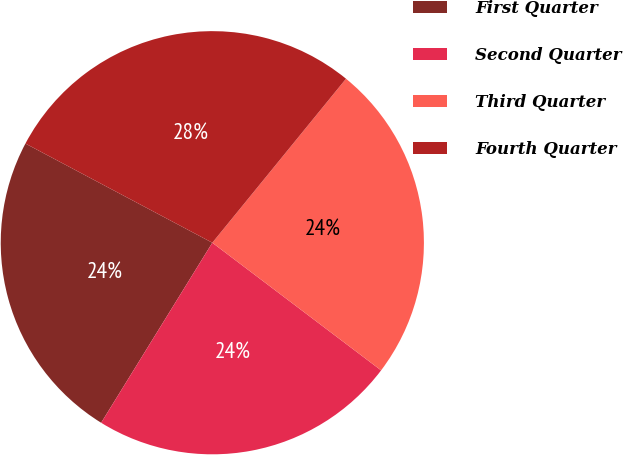Convert chart to OTSL. <chart><loc_0><loc_0><loc_500><loc_500><pie_chart><fcel>First Quarter<fcel>Second Quarter<fcel>Third Quarter<fcel>Fourth Quarter<nl><fcel>23.96%<fcel>23.5%<fcel>24.42%<fcel>28.12%<nl></chart> 